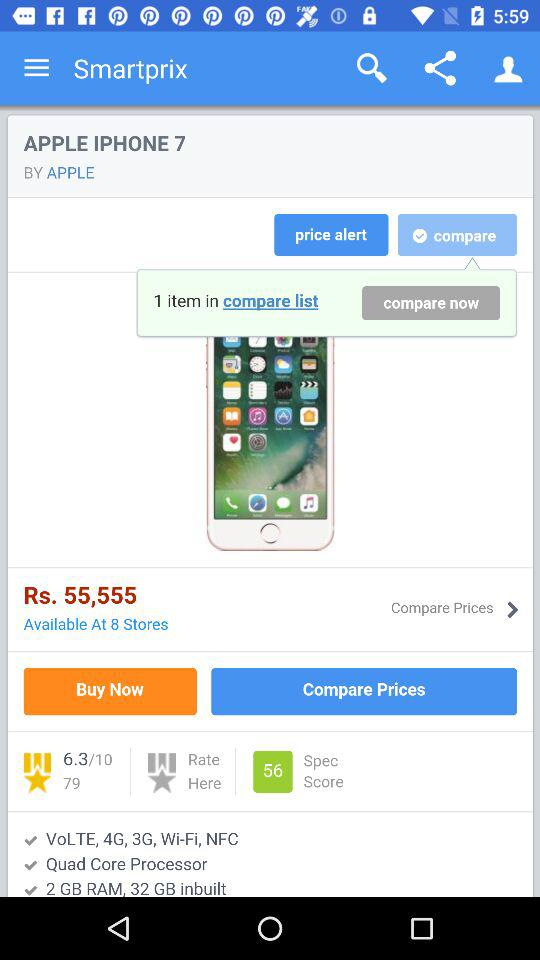What is the count of "Spec Score"? The "Spec Score" is 56. 